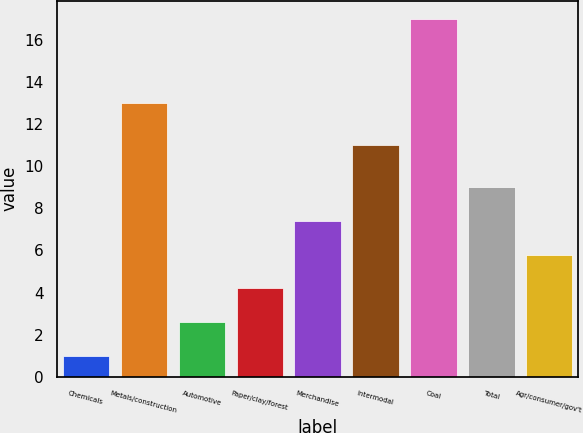<chart> <loc_0><loc_0><loc_500><loc_500><bar_chart><fcel>Chemicals<fcel>Metals/construction<fcel>Automotive<fcel>Paper/clay/forest<fcel>Merchandise<fcel>Intermodal<fcel>Coal<fcel>Total<fcel>Agr/consumer/gov't<nl><fcel>1<fcel>13<fcel>2.6<fcel>4.2<fcel>7.4<fcel>11<fcel>17<fcel>9<fcel>5.8<nl></chart> 